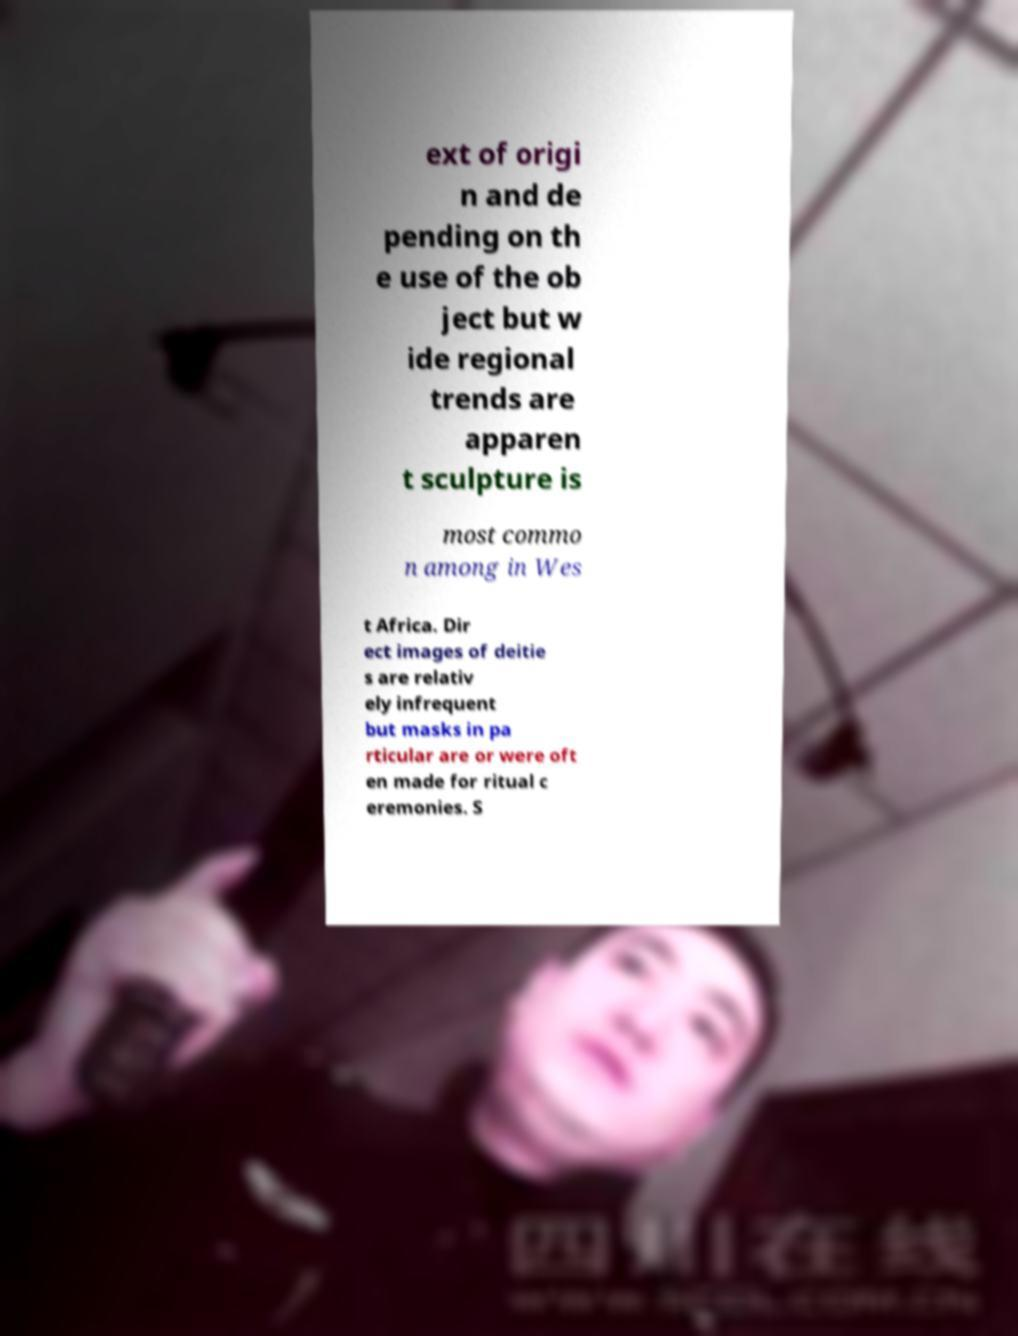Please identify and transcribe the text found in this image. ext of origi n and de pending on th e use of the ob ject but w ide regional trends are apparen t sculpture is most commo n among in Wes t Africa. Dir ect images of deitie s are relativ ely infrequent but masks in pa rticular are or were oft en made for ritual c eremonies. S 